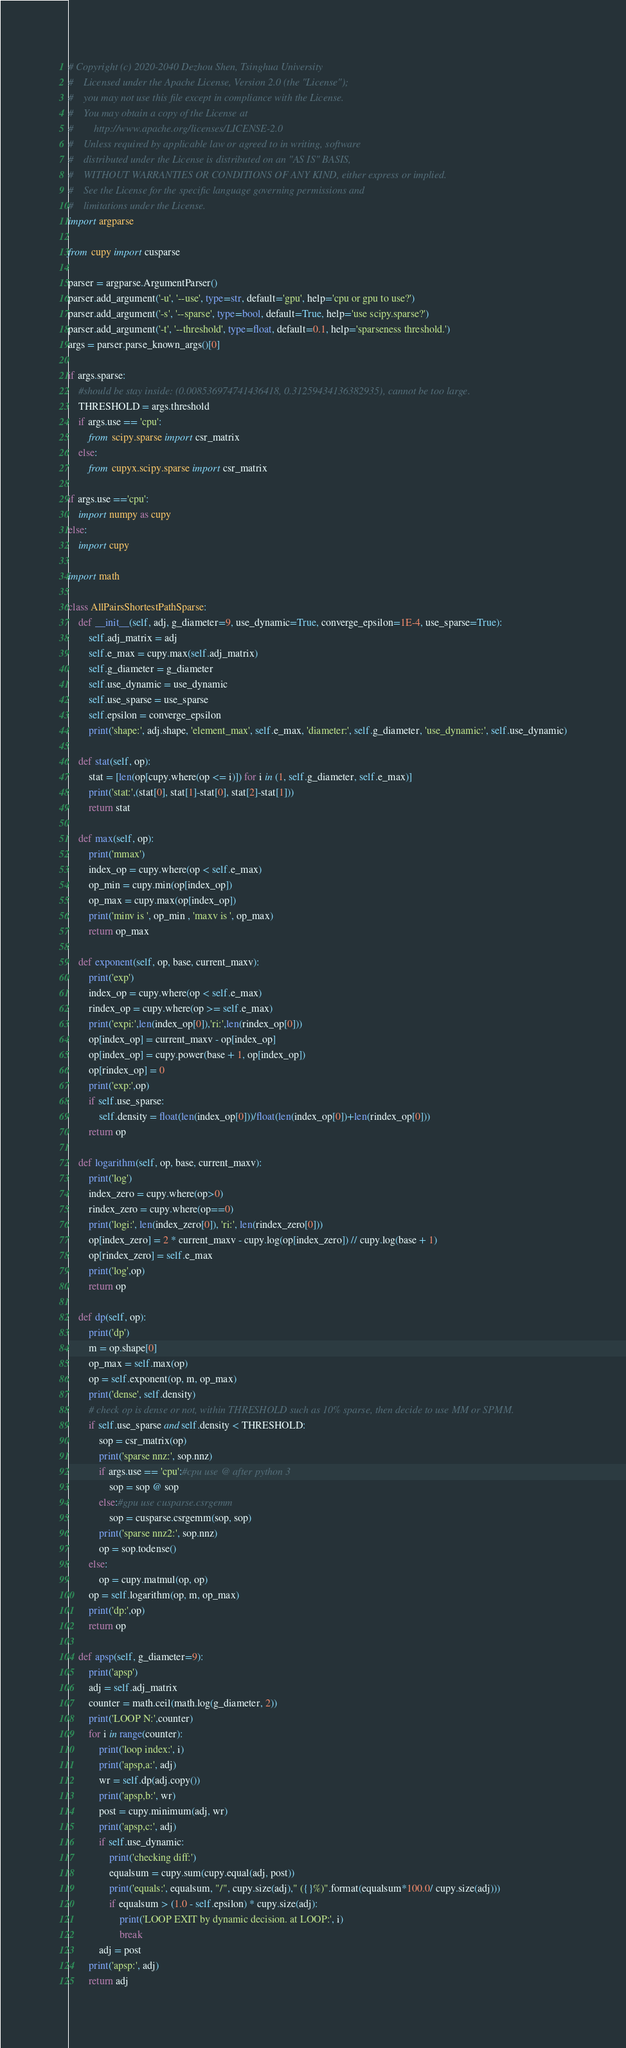Convert code to text. <code><loc_0><loc_0><loc_500><loc_500><_Python_># Copyright (c) 2020-2040 Dezhou Shen, Tsinghua University
#    Licensed under the Apache License, Version 2.0 (the "License");
#    you may not use this file except in compliance with the License.
#    You may obtain a copy of the License at
#        http://www.apache.org/licenses/LICENSE-2.0
#    Unless required by applicable law or agreed to in writing, software
#    distributed under the License is distributed on an "AS IS" BASIS,
#    WITHOUT WARRANTIES OR CONDITIONS OF ANY KIND, either express or implied.
#    See the License for the specific language governing permissions and
#    limitations under the License.
import argparse

from cupy import cusparse

parser = argparse.ArgumentParser()
parser.add_argument('-u', '--use', type=str, default='gpu', help='cpu or gpu to use?')
parser.add_argument('-s', '--sparse', type=bool, default=True, help='use scipy.sparse?')
parser.add_argument('-t', '--threshold', type=float, default=0.1, help='sparseness threshold.')
args = parser.parse_known_args()[0]

if args.sparse:
    #should be stay inside: (0.008536974741436418, 0.31259434136382935), cannot be too large.
    THRESHOLD = args.threshold
    if args.use == 'cpu':
        from scipy.sparse import csr_matrix
    else:
        from cupyx.scipy.sparse import csr_matrix

if args.use =='cpu':
    import numpy as cupy
else:
    import cupy

import math

class AllPairsShortestPathSparse:
    def __init__(self, adj, g_diameter=9, use_dynamic=True, converge_epsilon=1E-4, use_sparse=True):
        self.adj_matrix = adj
        self.e_max = cupy.max(self.adj_matrix)
        self.g_diameter = g_diameter
        self.use_dynamic = use_dynamic
        self.use_sparse = use_sparse
        self.epsilon = converge_epsilon
        print('shape:', adj.shape, 'element_max', self.e_max, 'diameter:', self.g_diameter, 'use_dynamic:', self.use_dynamic)

    def stat(self, op):
        stat = [len(op[cupy.where(op <= i)]) for i in (1, self.g_diameter, self.e_max)]
        print('stat:',(stat[0], stat[1]-stat[0], stat[2]-stat[1]))
        return stat

    def max(self, op):
        print('mmax')
        index_op = cupy.where(op < self.e_max)
        op_min = cupy.min(op[index_op])
        op_max = cupy.max(op[index_op])
        print('minv is ', op_min , 'maxv is ', op_max)
        return op_max

    def exponent(self, op, base, current_maxv):
        print('exp')
        index_op = cupy.where(op < self.e_max)
        rindex_op = cupy.where(op >= self.e_max)
        print('expi:',len(index_op[0]),'ri:',len(rindex_op[0]))
        op[index_op] = current_maxv - op[index_op]
        op[index_op] = cupy.power(base + 1, op[index_op])
        op[rindex_op] = 0
        print('exp:',op)
        if self.use_sparse:
            self.density = float(len(index_op[0]))/float(len(index_op[0])+len(rindex_op[0]))
        return op

    def logarithm(self, op, base, current_maxv):
        print('log')
        index_zero = cupy.where(op>0)
        rindex_zero = cupy.where(op==0)
        print('logi:', len(index_zero[0]), 'ri:', len(rindex_zero[0]))
        op[index_zero] = 2 * current_maxv - cupy.log(op[index_zero]) // cupy.log(base + 1)
        op[rindex_zero] = self.e_max
        print('log',op)
        return op

    def dp(self, op):
        print('dp')
        m = op.shape[0]
        op_max = self.max(op)
        op = self.exponent(op, m, op_max)
        print('dense', self.density)
        # check op is dense or not, within THRESHOLD such as 10% sparse, then decide to use MM or SPMM.
        if self.use_sparse and self.density < THRESHOLD:
            sop = csr_matrix(op)
            print('sparse nnz:', sop.nnz)
            if args.use == 'cpu':#cpu use @ after python 3
                sop = sop @ sop
            else:#gpu use cusparse.csrgemm
                sop = cusparse.csrgemm(sop, sop)
            print('sparse nnz2:', sop.nnz)
            op = sop.todense()
        else:
            op = cupy.matmul(op, op)
        op = self.logarithm(op, m, op_max)
        print('dp:',op)
        return op

    def apsp(self, g_diameter=9):
        print('apsp')
        adj = self.adj_matrix
        counter = math.ceil(math.log(g_diameter, 2))
        print('LOOP N:',counter)
        for i in range(counter):
            print('loop index:', i)
            print('apsp,a:', adj)
            wr = self.dp(adj.copy())
            print('apsp,b:', wr)
            post = cupy.minimum(adj, wr)
            print('apsp,c:', adj)
            if self.use_dynamic:
                print('checking diff:')
                equalsum = cupy.sum(cupy.equal(adj, post))
                print('equals:', equalsum, "/", cupy.size(adj)," ({}%)".format(equalsum*100.0/ cupy.size(adj)))
                if equalsum > (1.0 - self.epsilon) * cupy.size(adj):
                    print('LOOP EXIT by dynamic decision. at LOOP:', i)
                    break
            adj = post
        print('apsp:', adj)
        return adj
</code> 